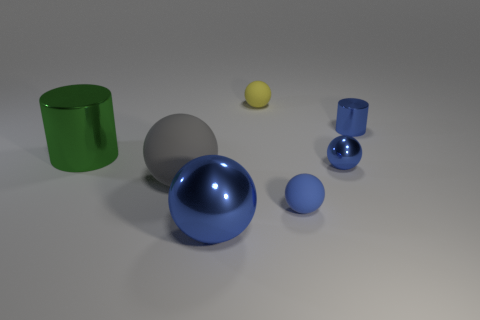Does the small metallic ball have the same color as the large rubber thing?
Provide a succinct answer. No. There is a big object that is the same color as the small cylinder; what is its shape?
Your answer should be compact. Sphere. There is a blue metallic thing that is the same size as the gray rubber sphere; what is its shape?
Ensure brevity in your answer.  Sphere. Are there fewer yellow spheres than large cyan matte cylinders?
Offer a very short reply. No. Are there any tiny yellow rubber balls that are on the left side of the tiny metal object behind the large cylinder?
Your response must be concise. Yes. There is a green object that is the same material as the large blue ball; what shape is it?
Your answer should be compact. Cylinder. Is there anything else of the same color as the small metal ball?
Offer a very short reply. Yes. There is a tiny yellow object that is the same shape as the big gray object; what material is it?
Keep it short and to the point. Rubber. How many other objects are there of the same size as the gray ball?
Give a very brief answer. 2. There is a rubber sphere that is the same color as the small metallic cylinder; what is its size?
Ensure brevity in your answer.  Small. 